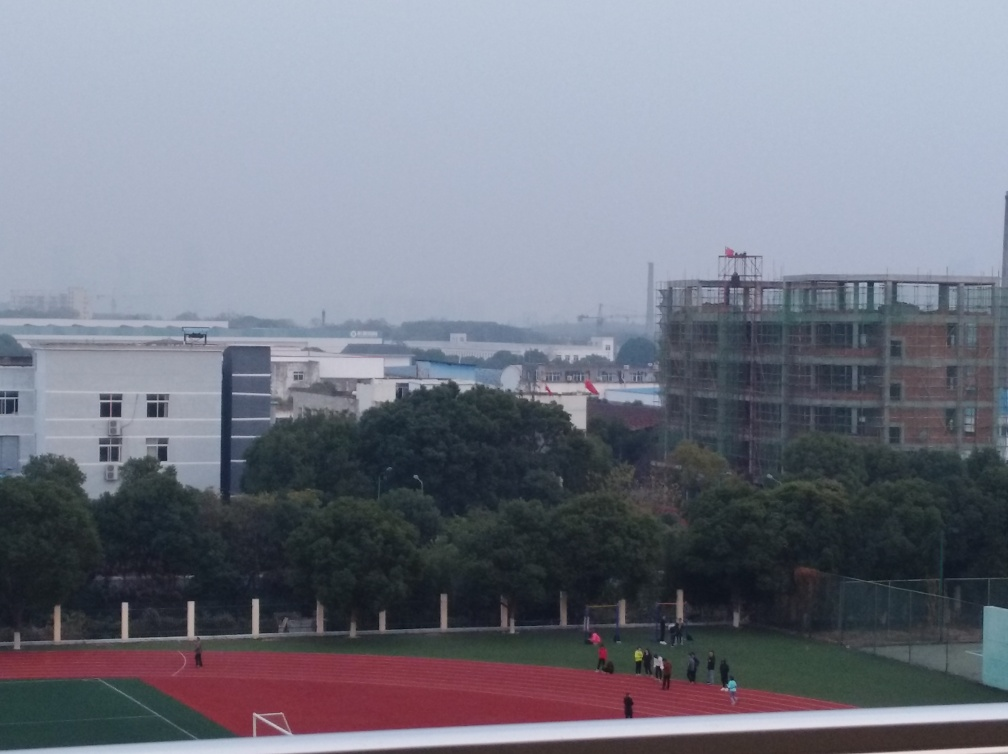What is the general mood or atmosphere conveyed by the image? The overall atmosphere appears serene and quiet. The lack of bright colors and the calm presence of people in the distance gives it a tranquil, possibly early morning vibe when the day is just starting and activities are beginning to pick up. 